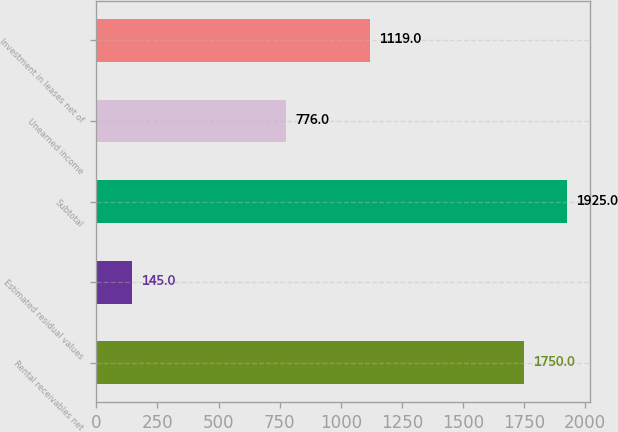<chart> <loc_0><loc_0><loc_500><loc_500><bar_chart><fcel>Rental receivables net<fcel>Estimated residual values<fcel>Subtotal<fcel>Unearned income<fcel>Investment in leases net of<nl><fcel>1750<fcel>145<fcel>1925<fcel>776<fcel>1119<nl></chart> 